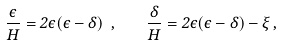<formula> <loc_0><loc_0><loc_500><loc_500>\frac { \dot { \epsilon } } { H } = 2 \epsilon ( \epsilon - \delta ) \ , \quad \frac { \dot { \delta } } { H } = 2 \epsilon ( \epsilon - \delta ) - \xi \, ,</formula> 